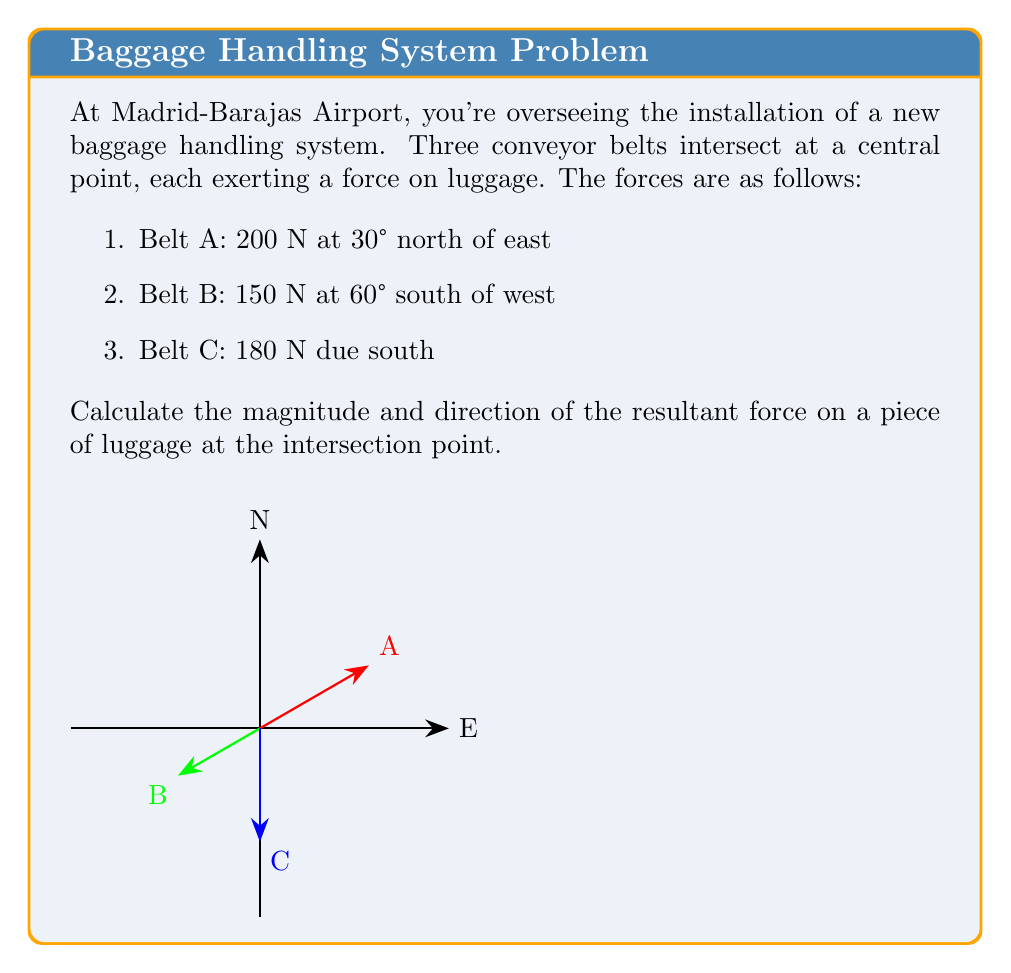Show me your answer to this math problem. Let's solve this problem step by step using vector addition:

1) First, we need to convert all forces into their x and y components:

   Belt A: $200 \angle 30°$
   $A_x = 200 \cos 30° = 200 \cdot \frac{\sqrt{3}}{2} = 100\sqrt{3}$ N
   $A_y = 200 \sin 30° = 200 \cdot \frac{1}{2} = 100$ N

   Belt B: $150 \angle 240°$ (60° south of west = 240° from east)
   $B_x = 150 \cos 240° = 150 \cdot (-\frac{1}{2}) = -75$ N
   $B_y = 150 \sin 240° = 150 \cdot (-\frac{\sqrt{3}}{2}) = -75\sqrt{3}$ N

   Belt C: $180 \angle 270°$ (due south = 270° from east)
   $C_x = 180 \cos 270° = 0$ N
   $C_y = 180 \sin 270° = -180$ N

2) Now, we sum up all the x-components and y-components:

   $\sum F_x = A_x + B_x + C_x = 100\sqrt{3} - 75 + 0 = 100\sqrt{3} - 75$ N
   $\sum F_y = A_y + B_y + C_y = 100 - 75\sqrt{3} - 180 = -75\sqrt{3} - 80$ N

3) The magnitude of the resultant force can be calculated using the Pythagorean theorem:

   $R = \sqrt{(\sum F_x)^2 + (\sum F_y)^2}$
   $R = \sqrt{(100\sqrt{3} - 75)^2 + (-75\sqrt{3} - 80)^2}$
   $R \approx 236.64$ N

4) The direction of the resultant force can be found using the arctangent function:

   $\theta = \tan^{-1}(\frac{\sum F_y}{\sum F_x})$
   $\theta = \tan^{-1}(\frac{-75\sqrt{3} - 80}{100\sqrt{3} - 75})$
   $\theta \approx -51.73°$

   Since this angle is negative, it means the force is 51.73° south of east.
Answer: $236.64$ N, $51.73°$ south of east 